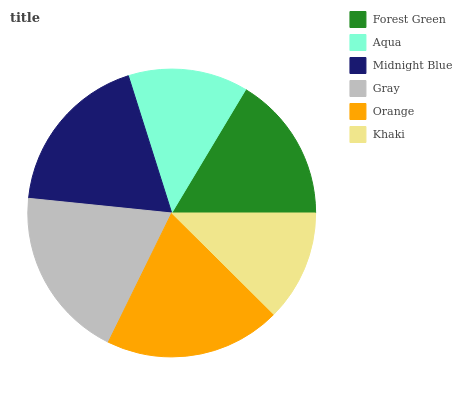Is Khaki the minimum?
Answer yes or no. Yes. Is Orange the maximum?
Answer yes or no. Yes. Is Aqua the minimum?
Answer yes or no. No. Is Aqua the maximum?
Answer yes or no. No. Is Forest Green greater than Aqua?
Answer yes or no. Yes. Is Aqua less than Forest Green?
Answer yes or no. Yes. Is Aqua greater than Forest Green?
Answer yes or no. No. Is Forest Green less than Aqua?
Answer yes or no. No. Is Midnight Blue the high median?
Answer yes or no. Yes. Is Forest Green the low median?
Answer yes or no. Yes. Is Khaki the high median?
Answer yes or no. No. Is Gray the low median?
Answer yes or no. No. 